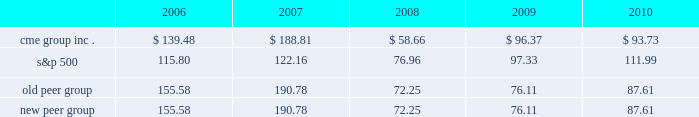Performance graph the following graph compares the cumulative five-year total return provided shareholders on our class a common stock relative to the cumulative total returns of the s&p 500 index and two customized peer groups .
The old peer group includes intercontinentalexchange , inc. , nyse euronext and the nasdaq omx group inc .
The new peer group is the same as the old peer group with the addition of cboe holdings , inc .
Which completed its initial public offering in june 2010 .
An investment of $ 100 ( with reinvestment of all dividends ) is assumed to have been made in our class a common stock , in the peer groups and the s&p 500 index on december 31 , 2005 and its relative performance is tracked through december 31 , 2010 .
Comparison of 5 year cumulative total return* among cme group inc. , the s&p 500 index , an old peer group and a new peer group 12/05 12/06 12/07 12/08 12/09 12/10 cme group inc .
S&p 500 old peer group *$ 100 invested on 12/31/05 in stock or index , including reinvestment of dividends .
Fiscal year ending december 31 .
Copyright a9 2011 s&p , a division of the mcgraw-hill companies inc .
All rights reserved .
New peer group the stock price performance included in this graph is not necessarily indicative of future stock price performance .

Did the cme group outperform the s&p 500? 
Computations: (93.73 > 111.99)
Answer: no. 